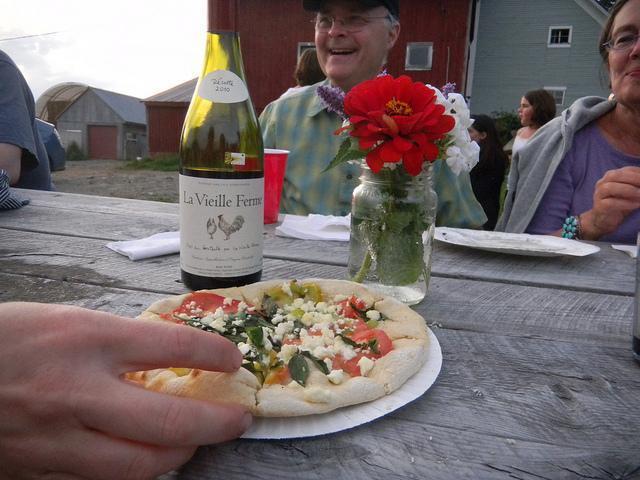How many glasses are on the table?
Give a very brief answer. 1. How many bottles are there?
Give a very brief answer. 1. How many slices of pizza?
Give a very brief answer. 4. How many people can you see?
Give a very brief answer. 5. 